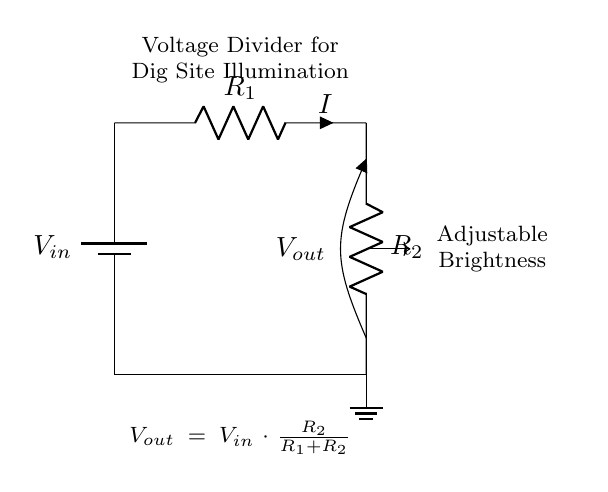What type of circuit is depicted? The circuit is a voltage divider, consisting of two resistors. This configuration is typically used to control the output voltage.
Answer: Voltage divider What are the components of the circuit? The components include a power supply (battery), two resistors labeled R1 and R2, a ground connection, and a lamp. These are the key elements shown in the diagram.
Answer: Battery, resistors, ground, lamp What does the output voltage depend on? The output voltage is determined by the ratio of R2 to the total resistance (R1 + R2) multiplied by the input voltage (Vin). This relationship is represented in the voltage divider equation present in the diagram.
Answer: R2 and R1 How can the brightness of the lamp be adjusted? The brightness can be adjusted by changing the values of R1 or R2. Altering the resistor values will change the output voltage, which affects the power delivered to the lamp.
Answer: By changing R1 or R2 What is the formula for the output voltage? The formula for the output voltage is stated in the diagram as Vout = Vin × (R2 / (R1 + R2)). This relationship captures how the input voltage relates to the output voltage based on the resistor values.
Answer: Vout = Vin × (R2 / (R1 + R2)) What is the significance of the ground in this circuit? The ground serves as a reference point for the circuit. It completes the circuit by providing a return path for current. Without a ground connection, the circuit would not function properly.
Answer: Reference point 